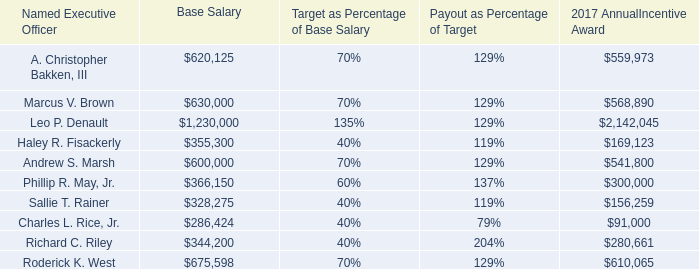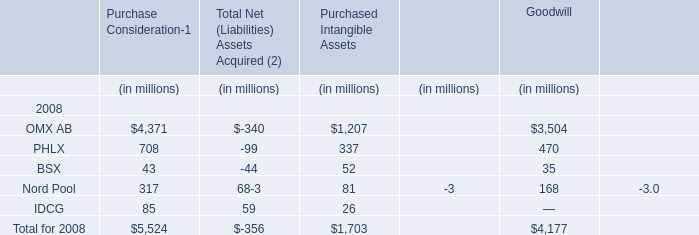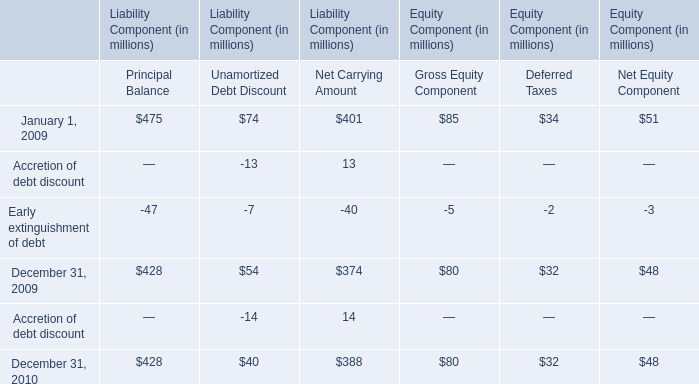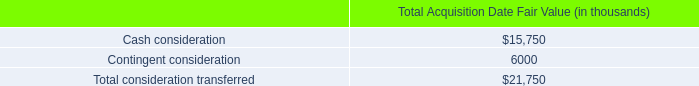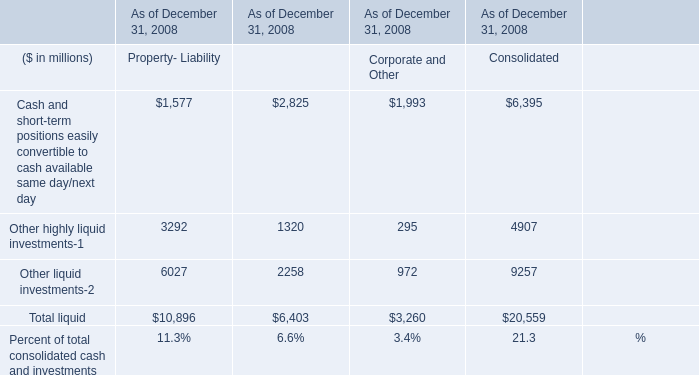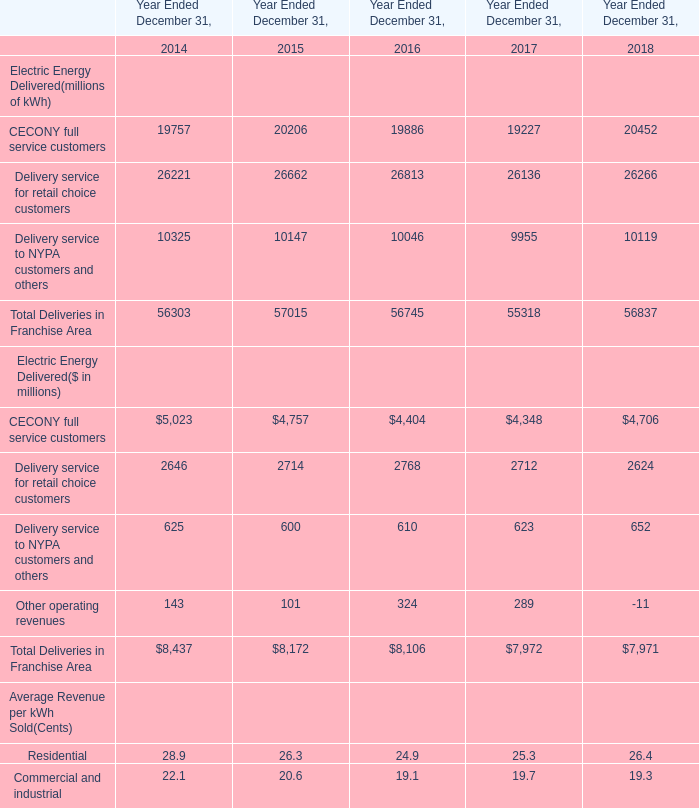What is the proportion of CECONY full service customers to the total in 2014? 
Computations: (5023 / 8437)
Answer: 0.59535. 